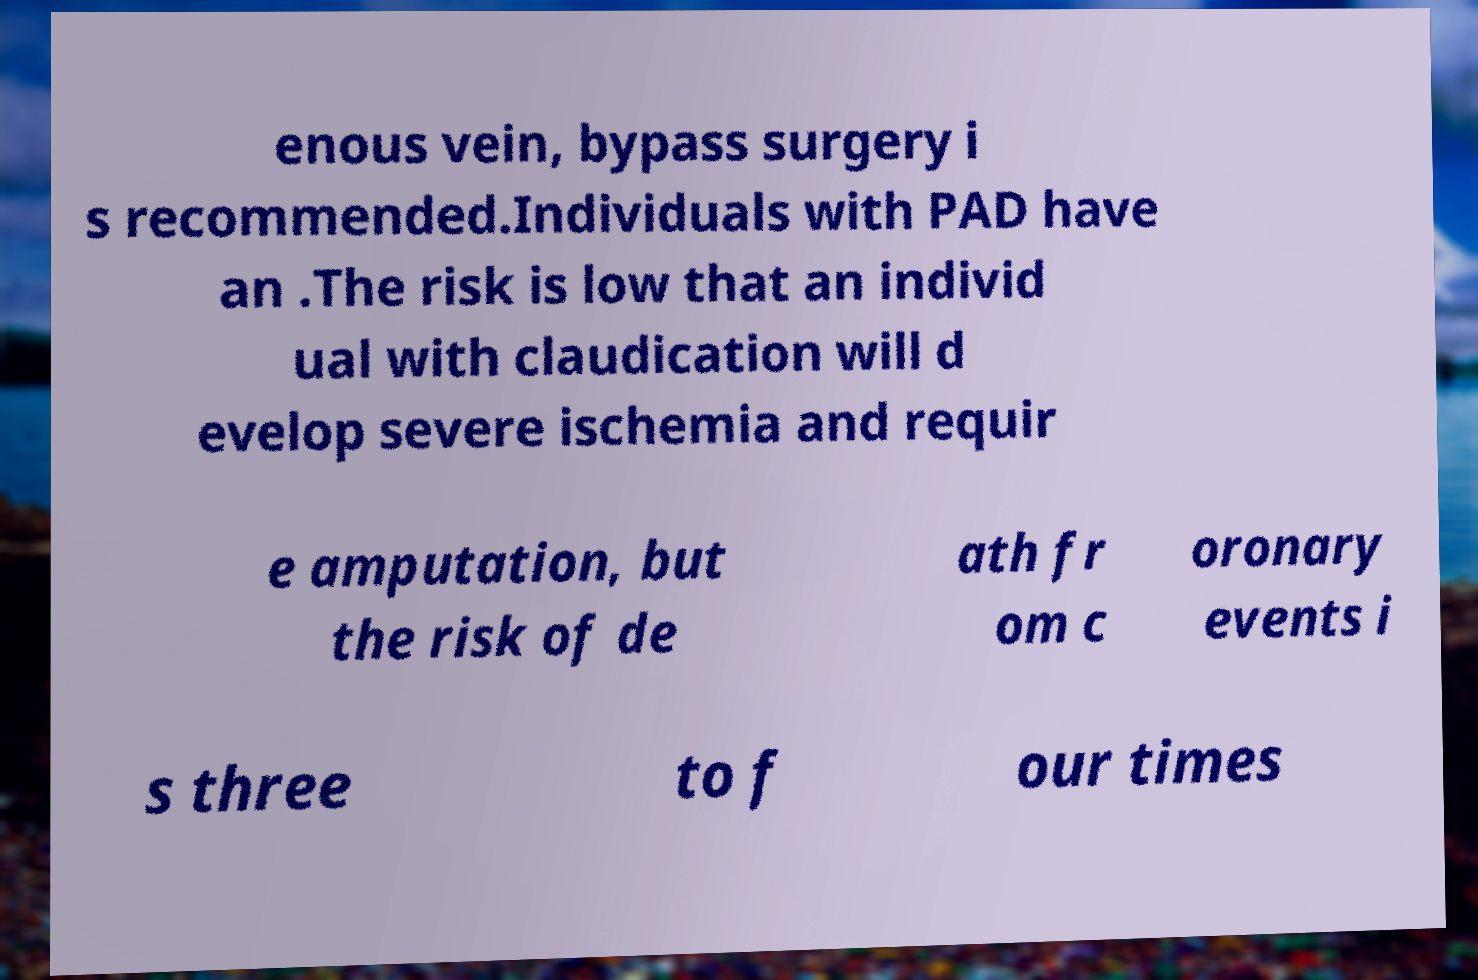Could you extract and type out the text from this image? enous vein, bypass surgery i s recommended.Individuals with PAD have an .The risk is low that an individ ual with claudication will d evelop severe ischemia and requir e amputation, but the risk of de ath fr om c oronary events i s three to f our times 